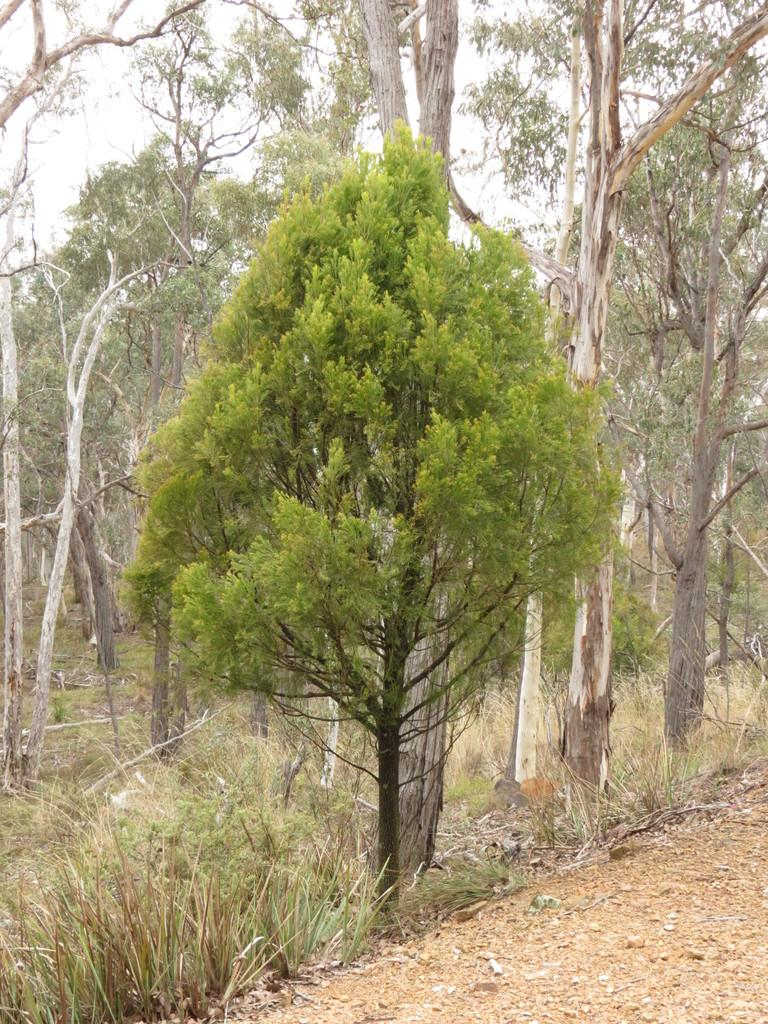What type of vegetation can be seen in the image? There are many trees, plants, and grass visible in the image. What part of the natural environment is visible at the bottom of the image? The ground is visible at the bottom of the image. What is visible in the background of the image? The sky is visible in the background of the image. What type of vessel is being used to transport the quince in the image? There is no vessel or quince present in the image. 